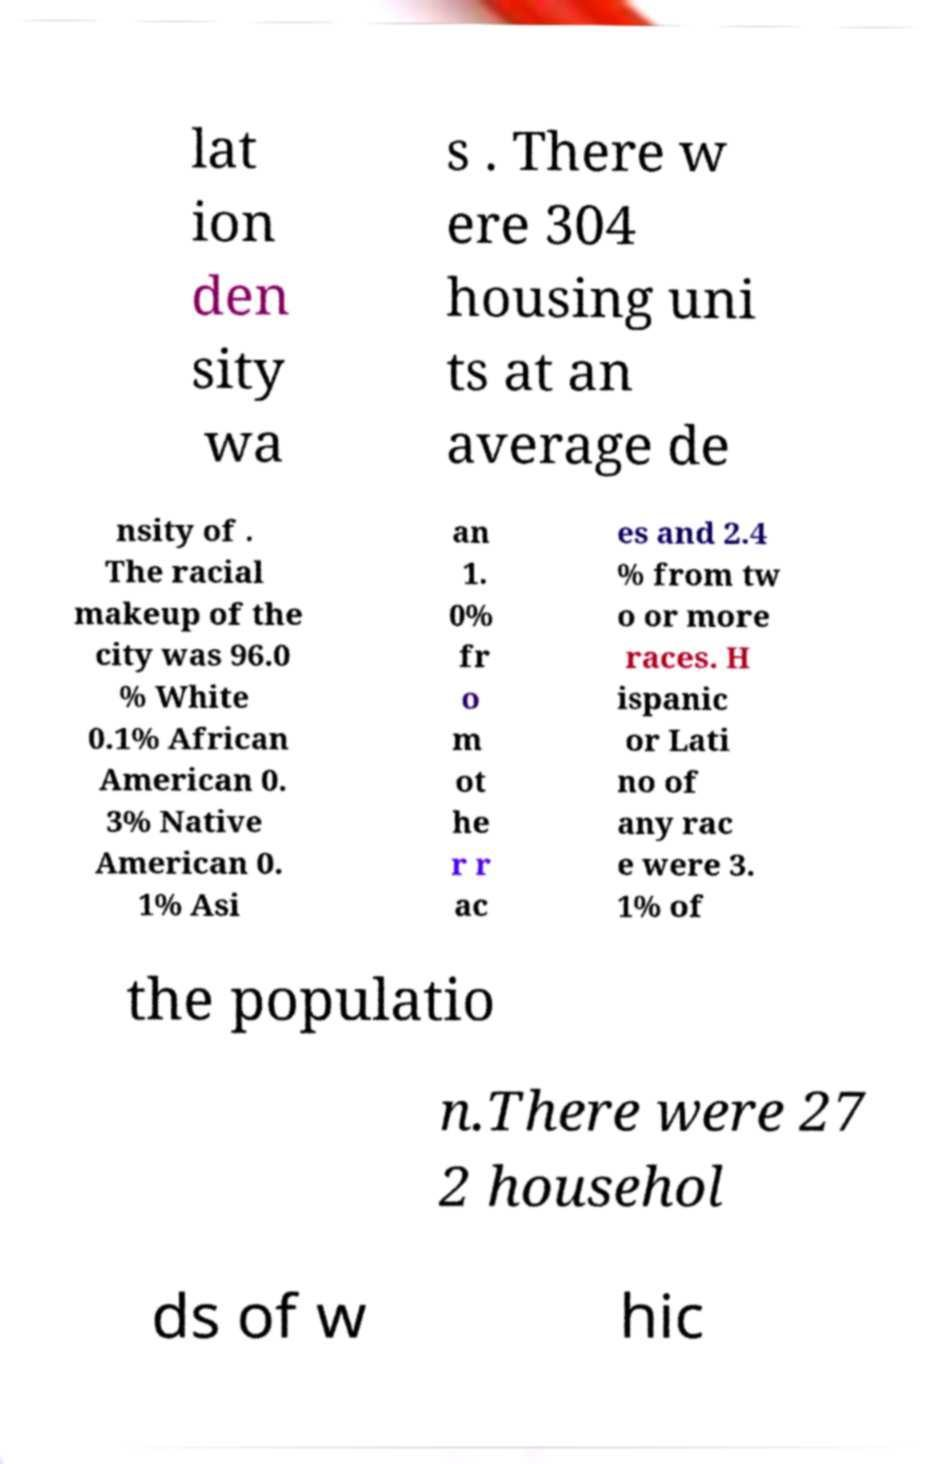Please read and relay the text visible in this image. What does it say? lat ion den sity wa s . There w ere 304 housing uni ts at an average de nsity of . The racial makeup of the city was 96.0 % White 0.1% African American 0. 3% Native American 0. 1% Asi an 1. 0% fr o m ot he r r ac es and 2.4 % from tw o or more races. H ispanic or Lati no of any rac e were 3. 1% of the populatio n.There were 27 2 househol ds of w hic 